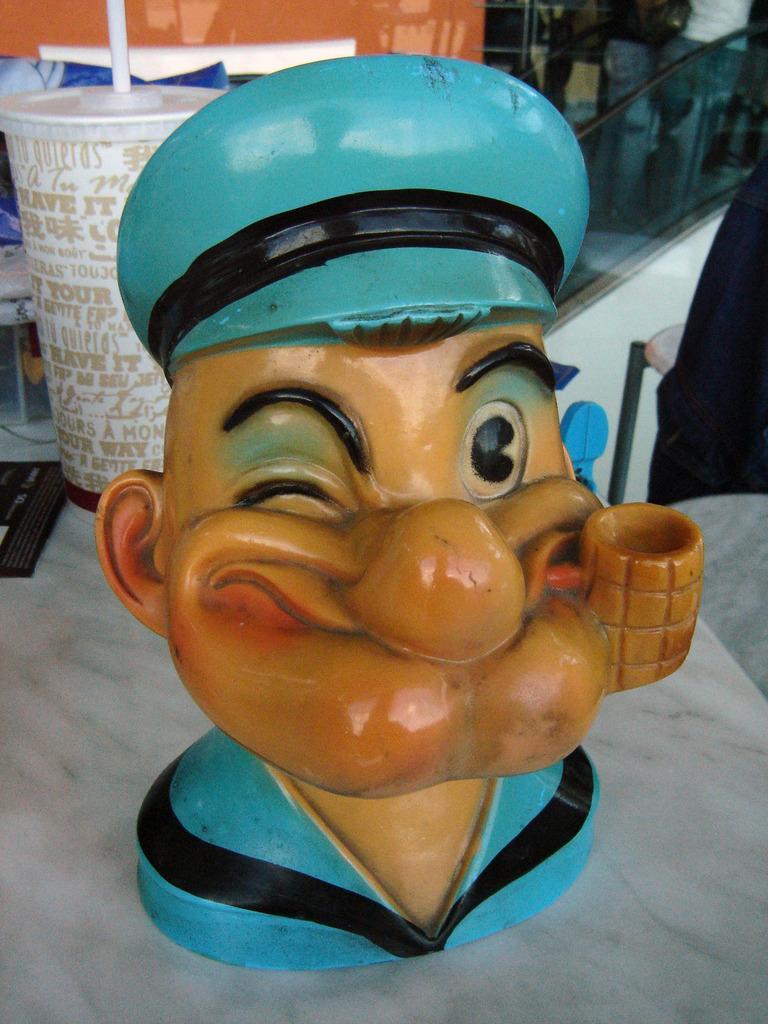Can you describe this image briefly? In the foreground of this picture we can see the sculpture of a toy is placed on the top of the table and we can see the glass and some other items are placed on the top of the table. In the background we can see there are some other objects and group of persons seems to be standing on the ground. 